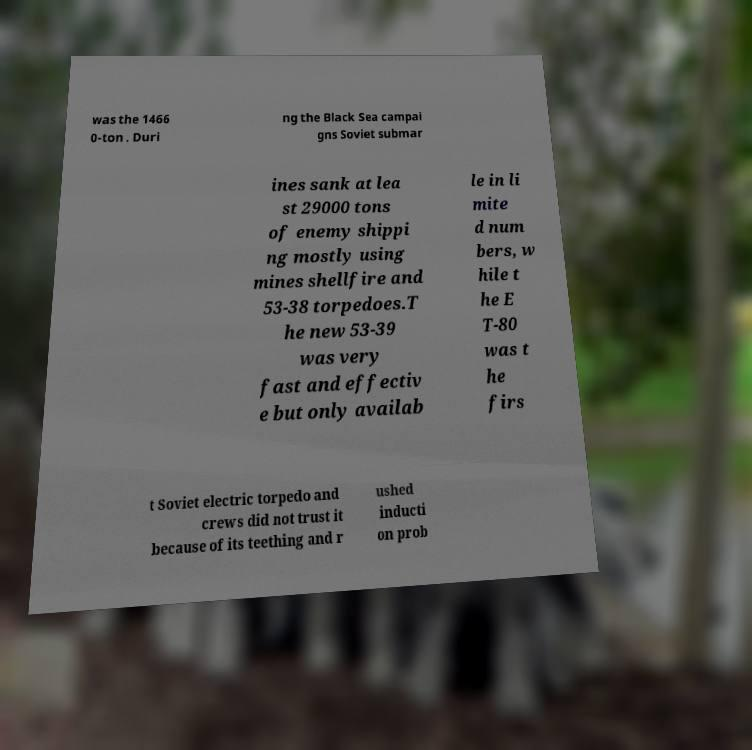Please read and relay the text visible in this image. What does it say? was the 1466 0-ton . Duri ng the Black Sea campai gns Soviet submar ines sank at lea st 29000 tons of enemy shippi ng mostly using mines shellfire and 53-38 torpedoes.T he new 53-39 was very fast and effectiv e but only availab le in li mite d num bers, w hile t he E T-80 was t he firs t Soviet electric torpedo and crews did not trust it because of its teething and r ushed inducti on prob 